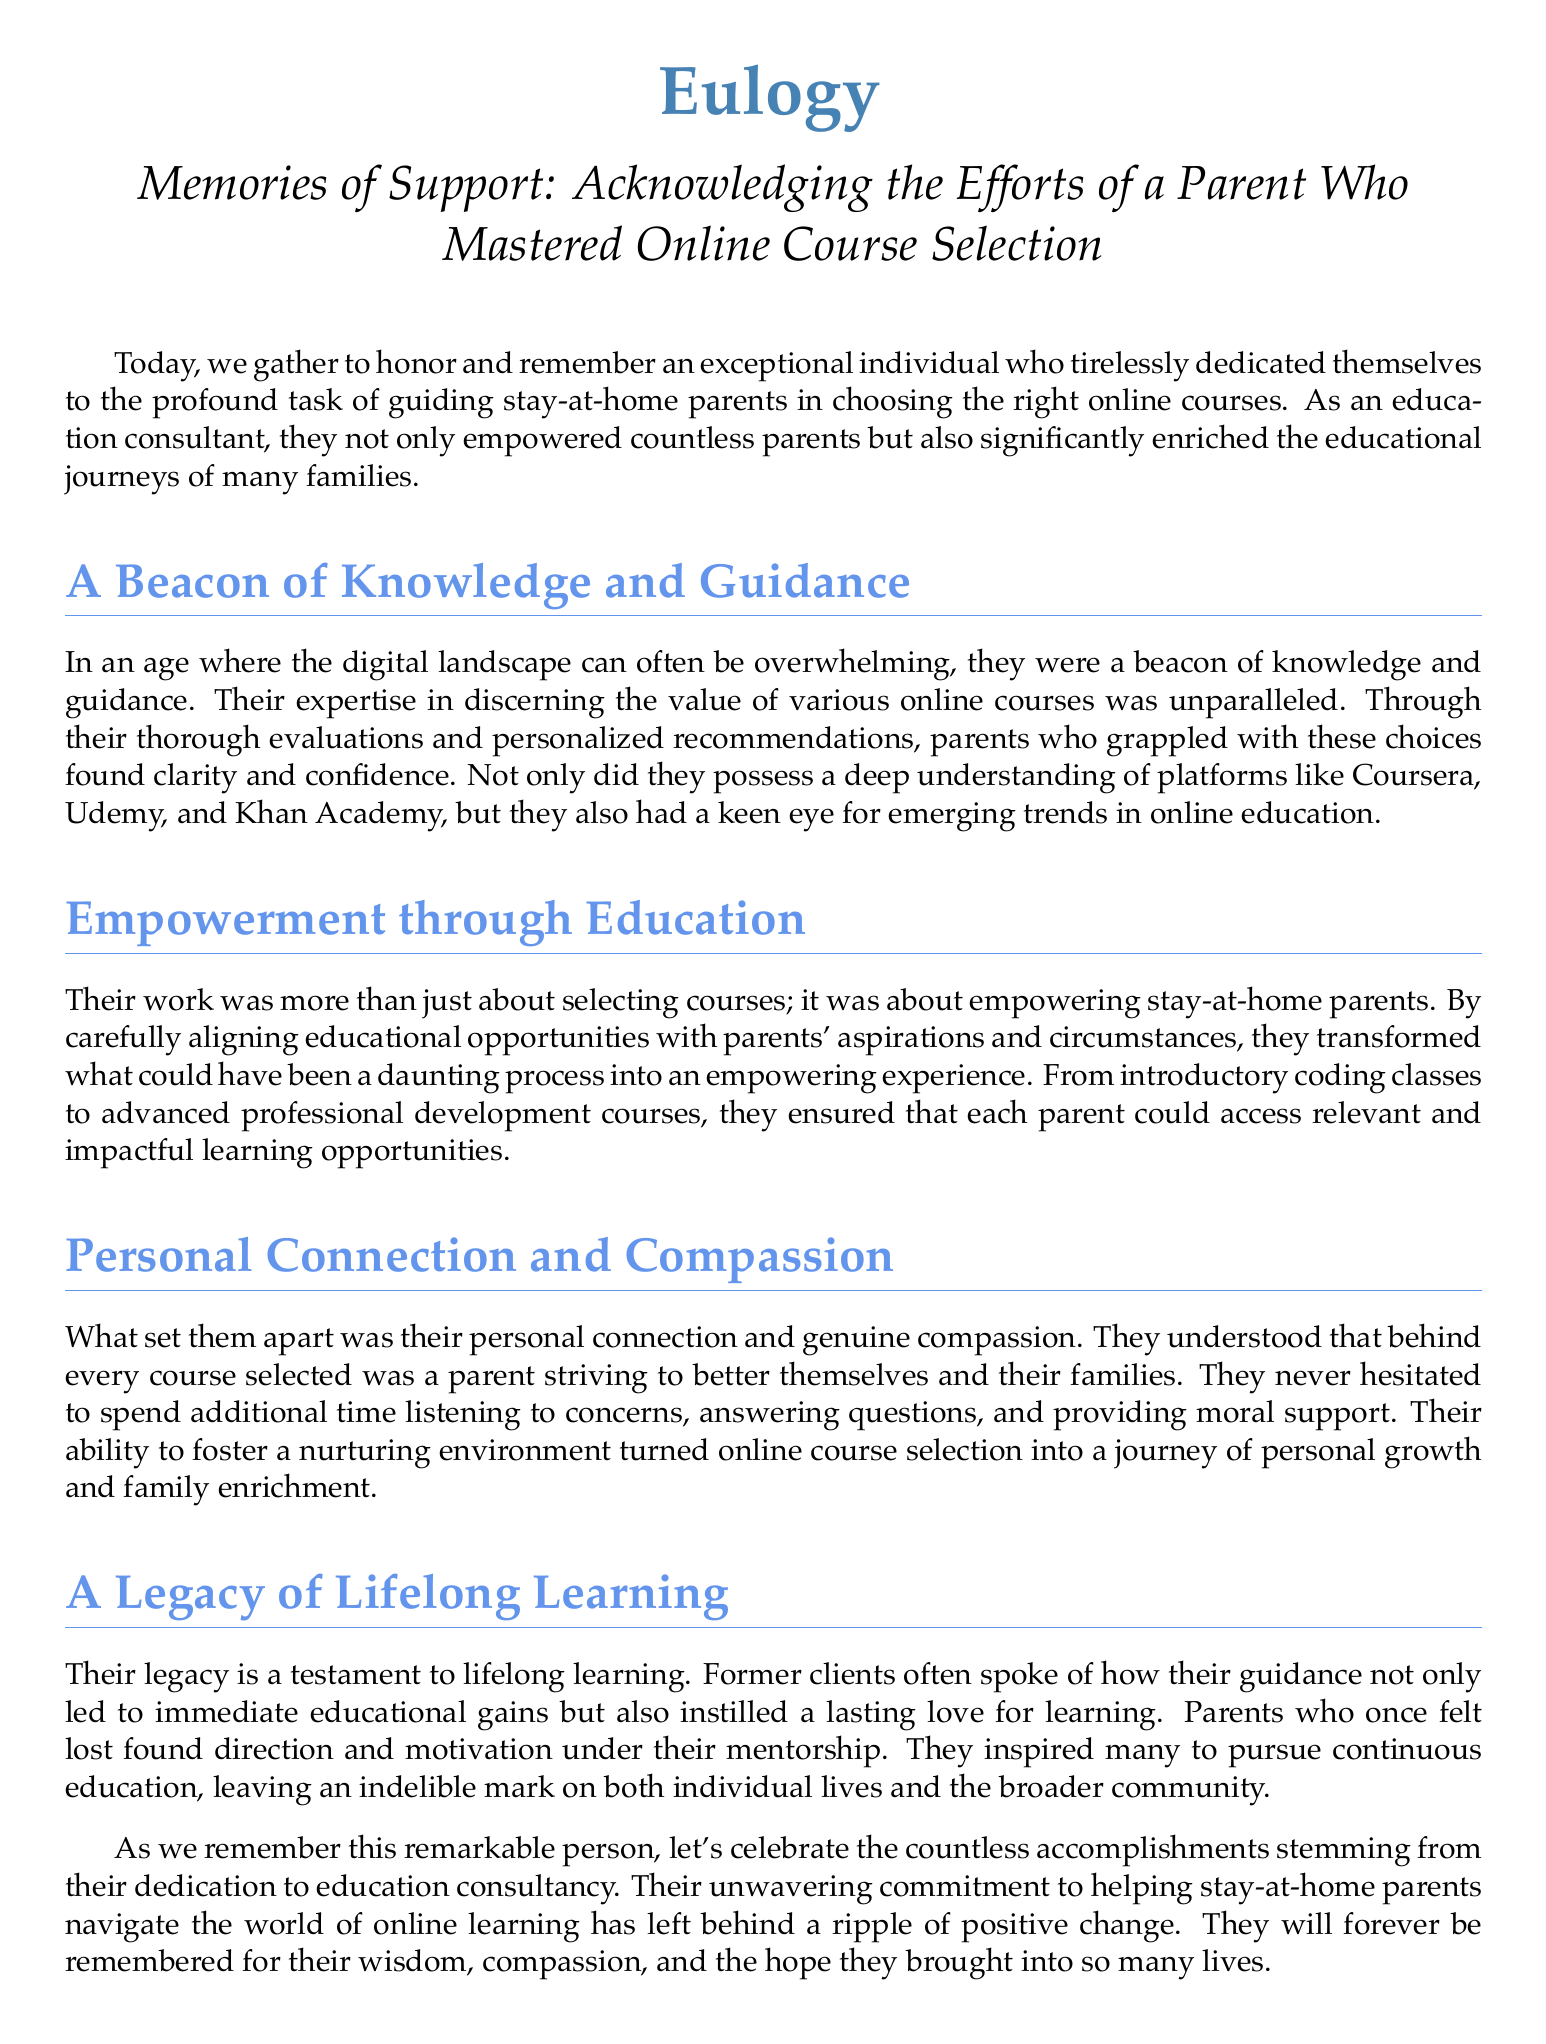What is the title of the eulogy? The title is explicitly stated at the beginning of the document, which is "Memories of Support: Acknowledging the Efforts of a Parent Who Mastered Online Course Selection."
Answer: Memories of Support: Acknowledging the Efforts of a Parent Who Mastered Online Course Selection Who did the individual dedicate themselves to helping? The document specifies that the individual dedicated themselves to guiding stay-at-home parents in selecting online courses.
Answer: stay-at-home parents Which platforms are mentioned as part of the individual's expertise? The document lists platforms such as Coursera, Udemy, and Khan Academy that the individual was knowledgeable about.
Answer: Coursera, Udemy, Khan Academy What type of legacy did the individual leave behind? The document describes the individual's legacy as one that is a testament to lifelong learning, indicating the positive impact they had.
Answer: lifelong learning What was the individual's approach to consulting? The document mentions that their work transformed online course selection into an empowering experience by carefully aligning educational opportunities.
Answer: empowering experience Why were parents inspired under the individual's mentorship? According to the document, parents were inspired because their guidance led to immediate educational gains and instilled a love for learning.
Answer: love for learning What is one key characteristic that set the individual apart? The document highlights their personal connection and genuine compassion as key characteristics that set them apart from others in the field.
Answer: compassion What did the individual provide apart from course recommendations? The document states that the individual provided moral support, indicating they offered more than just course recommendations.
Answer: moral support How did the individual impact the broader community? The document notes that the individual's mentorship left a ripple of positive change, affecting both individual lives and the broader community.
Answer: positive change 